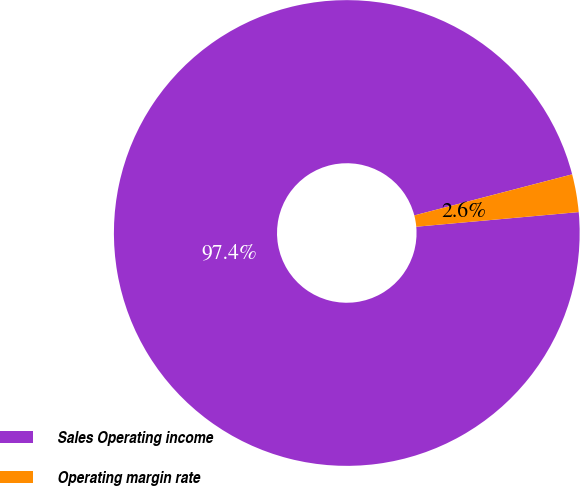Convert chart to OTSL. <chart><loc_0><loc_0><loc_500><loc_500><pie_chart><fcel>Sales Operating income<fcel>Operating margin rate<nl><fcel>97.38%<fcel>2.62%<nl></chart> 